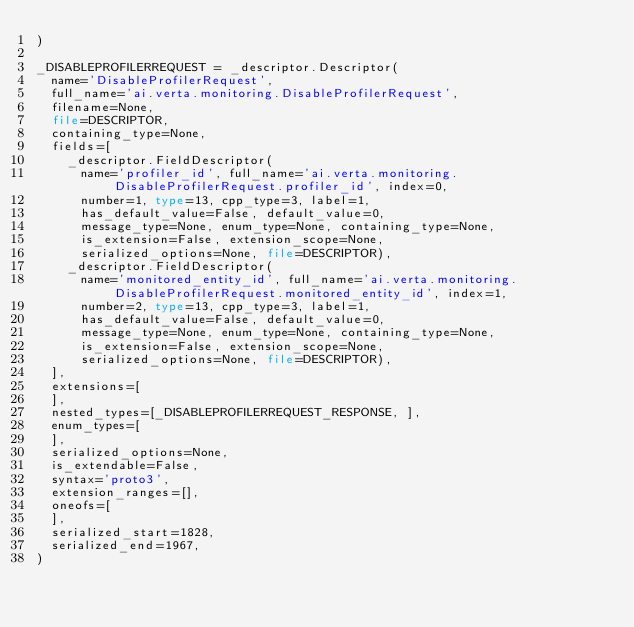<code> <loc_0><loc_0><loc_500><loc_500><_Python_>)

_DISABLEPROFILERREQUEST = _descriptor.Descriptor(
  name='DisableProfilerRequest',
  full_name='ai.verta.monitoring.DisableProfilerRequest',
  filename=None,
  file=DESCRIPTOR,
  containing_type=None,
  fields=[
    _descriptor.FieldDescriptor(
      name='profiler_id', full_name='ai.verta.monitoring.DisableProfilerRequest.profiler_id', index=0,
      number=1, type=13, cpp_type=3, label=1,
      has_default_value=False, default_value=0,
      message_type=None, enum_type=None, containing_type=None,
      is_extension=False, extension_scope=None,
      serialized_options=None, file=DESCRIPTOR),
    _descriptor.FieldDescriptor(
      name='monitored_entity_id', full_name='ai.verta.monitoring.DisableProfilerRequest.monitored_entity_id', index=1,
      number=2, type=13, cpp_type=3, label=1,
      has_default_value=False, default_value=0,
      message_type=None, enum_type=None, containing_type=None,
      is_extension=False, extension_scope=None,
      serialized_options=None, file=DESCRIPTOR),
  ],
  extensions=[
  ],
  nested_types=[_DISABLEPROFILERREQUEST_RESPONSE, ],
  enum_types=[
  ],
  serialized_options=None,
  is_extendable=False,
  syntax='proto3',
  extension_ranges=[],
  oneofs=[
  ],
  serialized_start=1828,
  serialized_end=1967,
)

</code> 